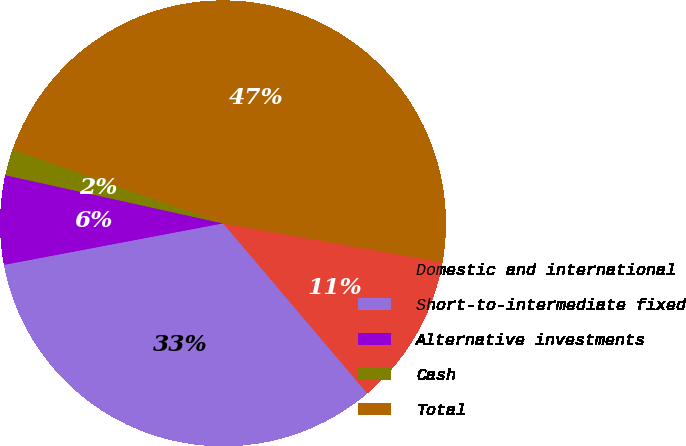Convert chart. <chart><loc_0><loc_0><loc_500><loc_500><pie_chart><fcel>Domestic and international<fcel>Short-to-intermediate fixed<fcel>Alternative investments<fcel>Cash<fcel>Total<nl><fcel>11.01%<fcel>33.21%<fcel>6.45%<fcel>1.9%<fcel>47.44%<nl></chart> 